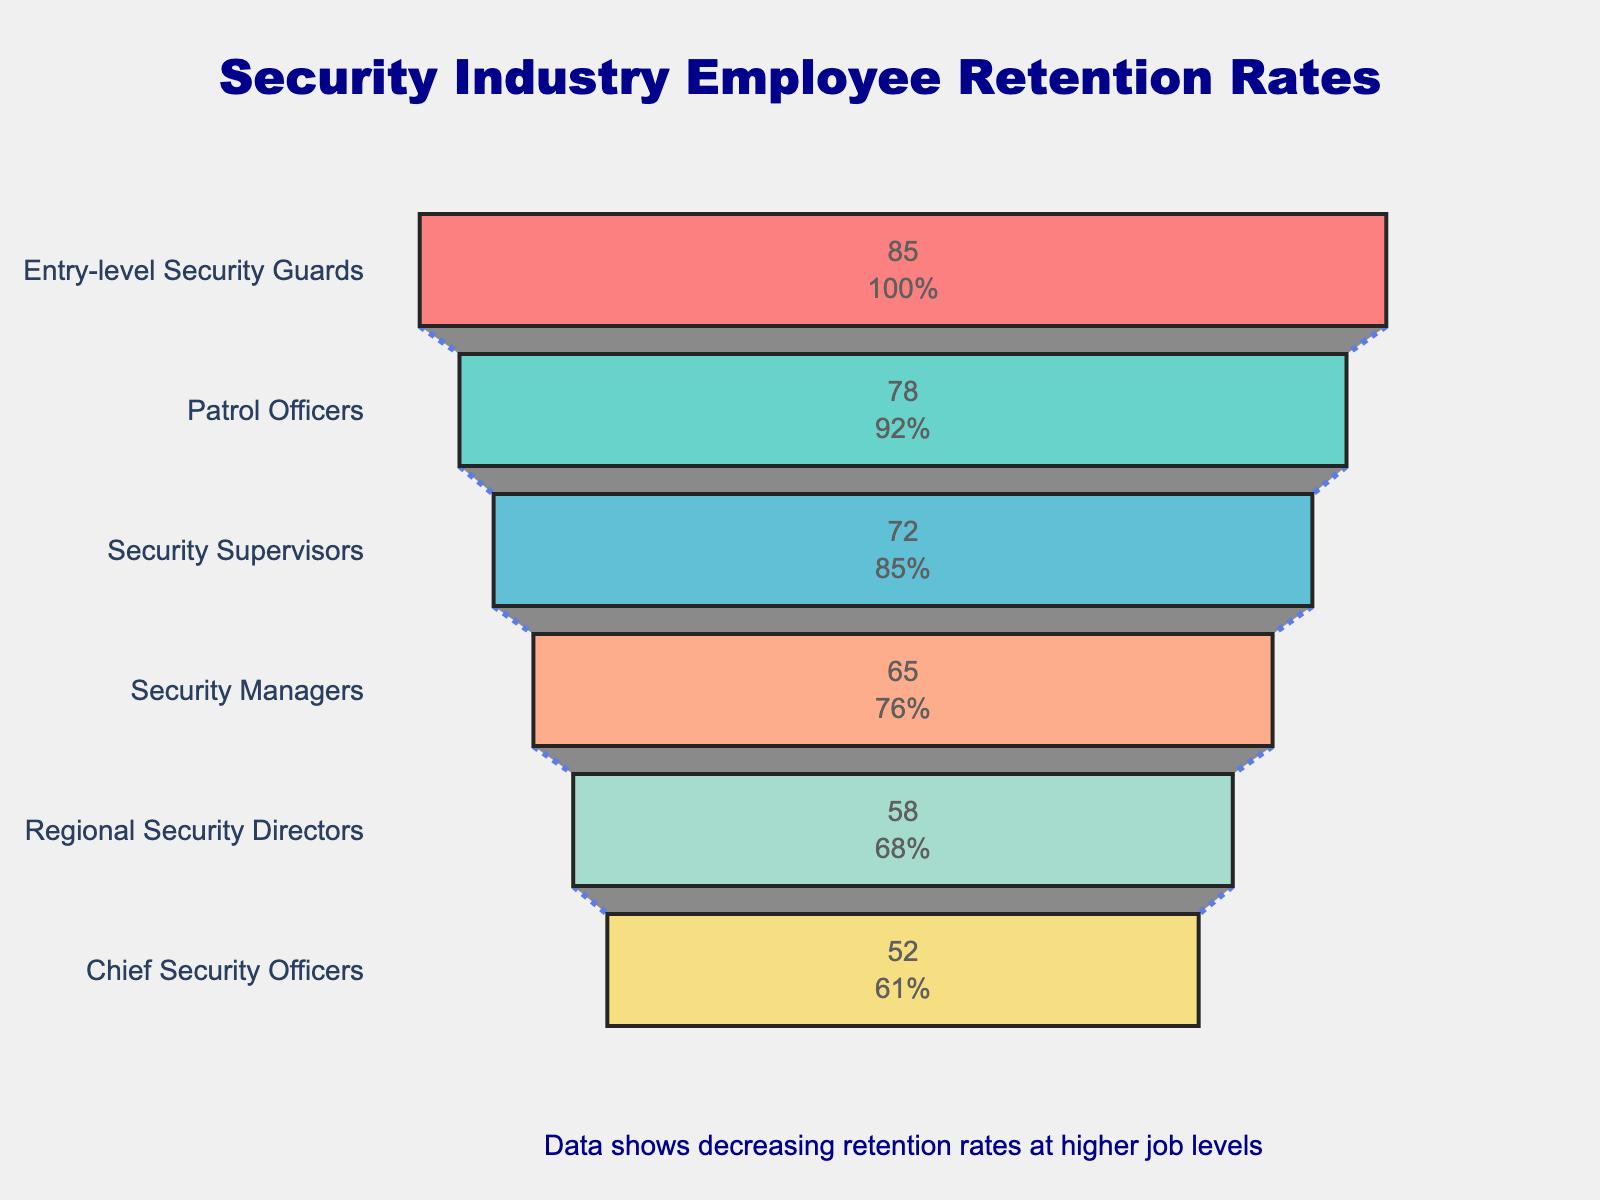What's the title of the figure? The title is typically located at the top center of the plot. By looking at the figure, we can see the title displayed there.
Answer: Security Industry Employee Retention Rates What's the retention rate for Chief Security Officers? Look at the section labeled "Chief Security Officers" in the funnel chart, and read the retention rate specified inside it.
Answer: 52% Which job level has the highest retention rate? Scan the funnel chart columns and find the one with the highest percentage value. It is the first level mentioned in the chart.
Answer: Entry-level Security Guards What is the difference in retention rates between Security Managers and Security Supervisors? Look at the funnel sections for both job levels. Security Managers have a retention rate of 65%, and Security Supervisors have 72%. Calculate the difference: 72% - 65%.
Answer: 7% What trend do you observe in employee retention rates as job levels increase? Observe the positions and percentages across different job levels in the funnel chart. Identify the general pattern shown.
Answer: Retention rates decrease as job levels increase Which job levels have retention rates below 60%? Examine the funnel chart, focusing on percentages lower than 60%. Identify the job levels with these percentages.
Answer: Regional Security Directors, Chief Security Officers Calculate the average retention rate for the four middle job levels: Patrol Officers, Security Supervisors, Security Managers, and Regional Security Directors. Find the retention rates for these levels (78%, 72%, 65%, and 58%, respectively). Add them up and divide by the number of levels: (78 + 72 + 65 + 58) / 4.
Answer: 68.25% Compare the retention rates between the entry-level Security Guards and Chief Security Officers. How many percentage points higher is the retention rate for the entry-level Guards? Find the retention rates for both levels: 85% for Entry-level Security Guards and 52% for Chief Security Officers. Subtract the lower rate from the higher one: 85% - 52%.
Answer: 33% What can be inferred about the challenges faced by the security industry in retaining employees at higher job levels? Based on the observation that the funnel narrows as job levels increase, it indicates decreasing retention rates at higher levels. This suggests the industry faces greater challenges in retaining top-level employees.
Answer: Higher job levels have lower retention rates indicating retention challenges How much does the retention rate decrease from Entry-level Security Guards to Regional Security Directors? Calculate the decrease between Entry-level Security Guards (85%) and Regional Security Directors (58%). Subtract the lower rate from the higher: 85% - 58%.
Answer: 27% 